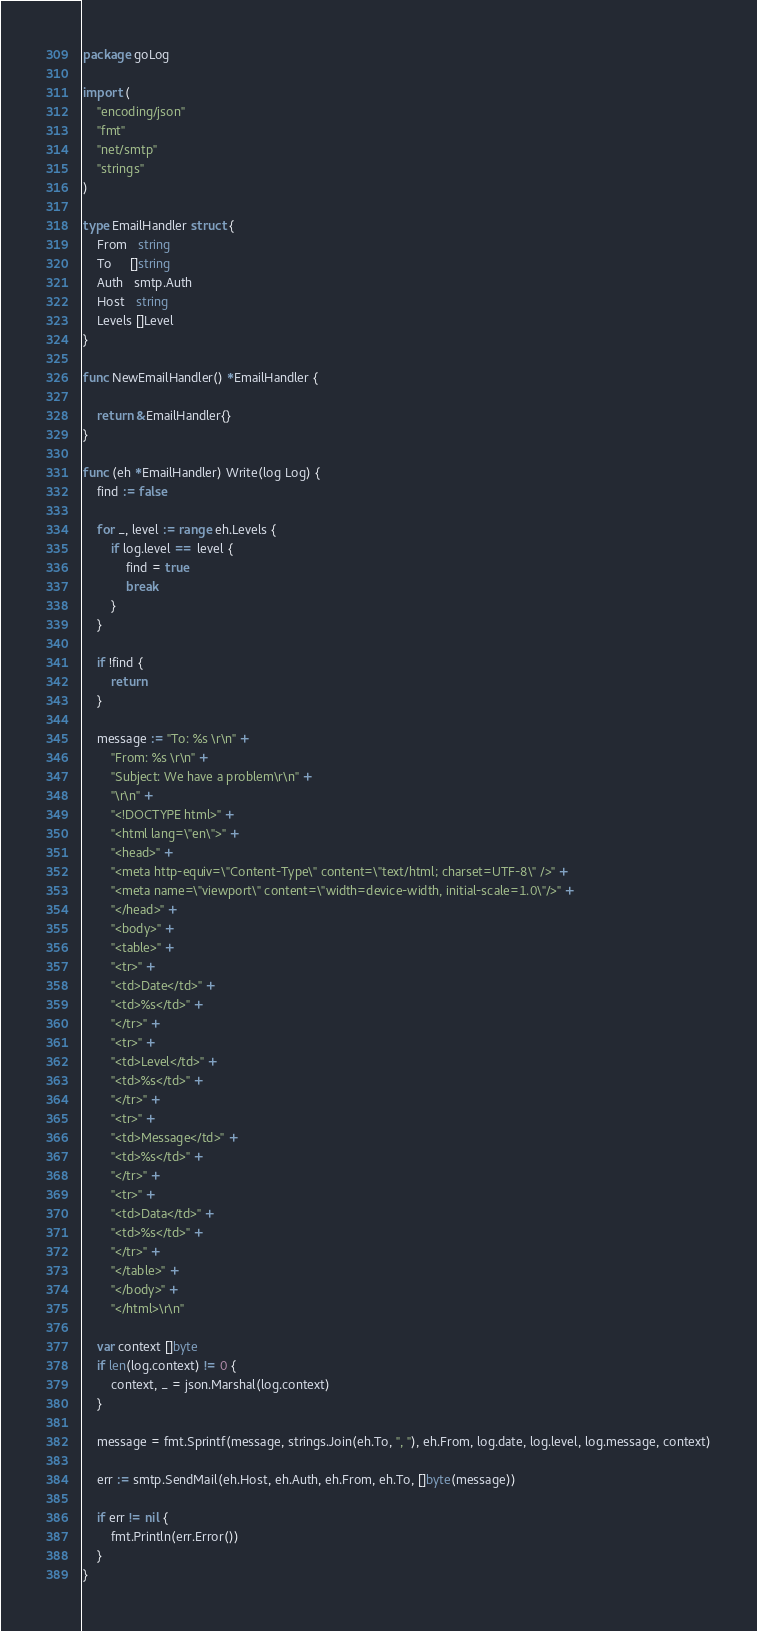Convert code to text. <code><loc_0><loc_0><loc_500><loc_500><_Go_>package goLog

import (
	"encoding/json"
	"fmt"
	"net/smtp"
	"strings"
)

type EmailHandler struct {
	From   string
	To     []string
	Auth   smtp.Auth
	Host   string
	Levels []Level
}

func NewEmailHandler() *EmailHandler {

	return &EmailHandler{}
}

func (eh *EmailHandler) Write(log Log) {
	find := false

	for _, level := range eh.Levels {
		if log.level == level {
			find = true
			break
		}
	}

	if !find {
		return
	}

	message := "To: %s \r\n" +
		"From: %s \r\n" +
		"Subject: We have a problem\r\n" +
		"\r\n" +
		"<!DOCTYPE html>" +
		"<html lang=\"en\">" +
		"<head>" +
		"<meta http-equiv=\"Content-Type\" content=\"text/html; charset=UTF-8\" />" +
		"<meta name=\"viewport\" content=\"width=device-width, initial-scale=1.0\"/>" +
		"</head>" +
		"<body>" +
		"<table>" +
		"<tr>" +
		"<td>Date</td>" +
		"<td>%s</td>" +
		"</tr>" +
		"<tr>" +
		"<td>Level</td>" +
		"<td>%s</td>" +
		"</tr>" +
		"<tr>" +
		"<td>Message</td>" +
		"<td>%s</td>" +
		"</tr>" +
		"<tr>" +
		"<td>Data</td>" +
		"<td>%s</td>" +
		"</tr>" +
		"</table>" +
		"</body>" +
		"</html>\r\n"

	var context []byte
	if len(log.context) != 0 {
		context, _ = json.Marshal(log.context)
	}

	message = fmt.Sprintf(message, strings.Join(eh.To, ", "), eh.From, log.date, log.level, log.message, context)

	err := smtp.SendMail(eh.Host, eh.Auth, eh.From, eh.To, []byte(message))

	if err != nil {
		fmt.Println(err.Error())
	}
}
</code> 